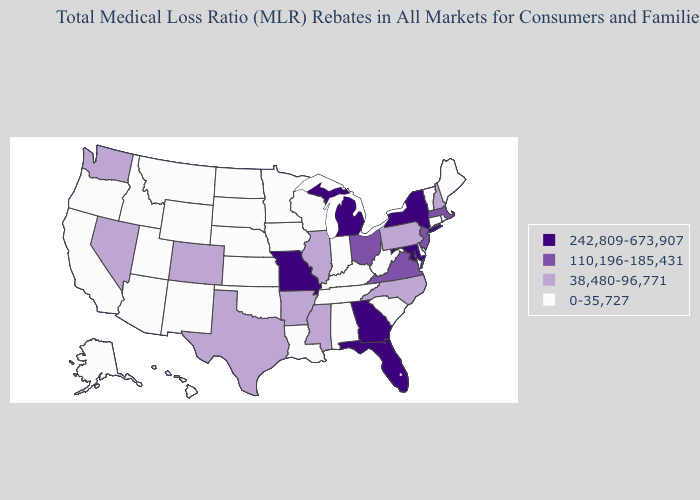Does Arkansas have a lower value than New York?
Keep it brief. Yes. What is the highest value in states that border New Mexico?
Be succinct. 38,480-96,771. Name the states that have a value in the range 242,809-673,907?
Quick response, please. Florida, Georgia, Maryland, Michigan, Missouri, New York. Name the states that have a value in the range 0-35,727?
Write a very short answer. Alabama, Alaska, Arizona, California, Connecticut, Delaware, Hawaii, Idaho, Indiana, Iowa, Kansas, Kentucky, Louisiana, Maine, Minnesota, Montana, Nebraska, New Mexico, North Dakota, Oklahoma, Oregon, Rhode Island, South Carolina, South Dakota, Tennessee, Utah, Vermont, West Virginia, Wisconsin, Wyoming. What is the value of Indiana?
Be succinct. 0-35,727. What is the lowest value in the West?
Quick response, please. 0-35,727. What is the value of Alaska?
Be succinct. 0-35,727. Name the states that have a value in the range 110,196-185,431?
Concise answer only. Massachusetts, New Jersey, Ohio, Virginia. Name the states that have a value in the range 110,196-185,431?
Be succinct. Massachusetts, New Jersey, Ohio, Virginia. Is the legend a continuous bar?
Give a very brief answer. No. What is the lowest value in states that border Kentucky?
Be succinct. 0-35,727. Which states have the lowest value in the Northeast?
Write a very short answer. Connecticut, Maine, Rhode Island, Vermont. How many symbols are there in the legend?
Quick response, please. 4. Is the legend a continuous bar?
Concise answer only. No. Does the map have missing data?
Write a very short answer. No. 